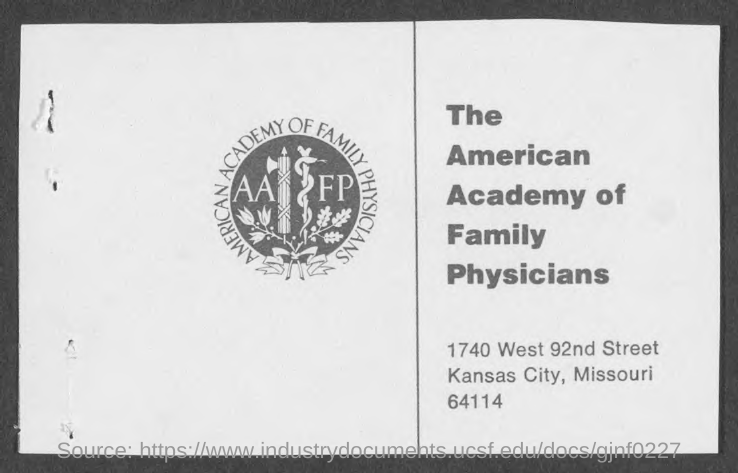What is the address of the american academy of family physicians?
Your answer should be very brief. 1740 WEST 92ND STREET KANSAS CITY, MISSOURI 64114. What does aafp stand for?
Provide a succinct answer. THE AMERICAN ACADEMY OF FAMILY PHYSICIANS. 